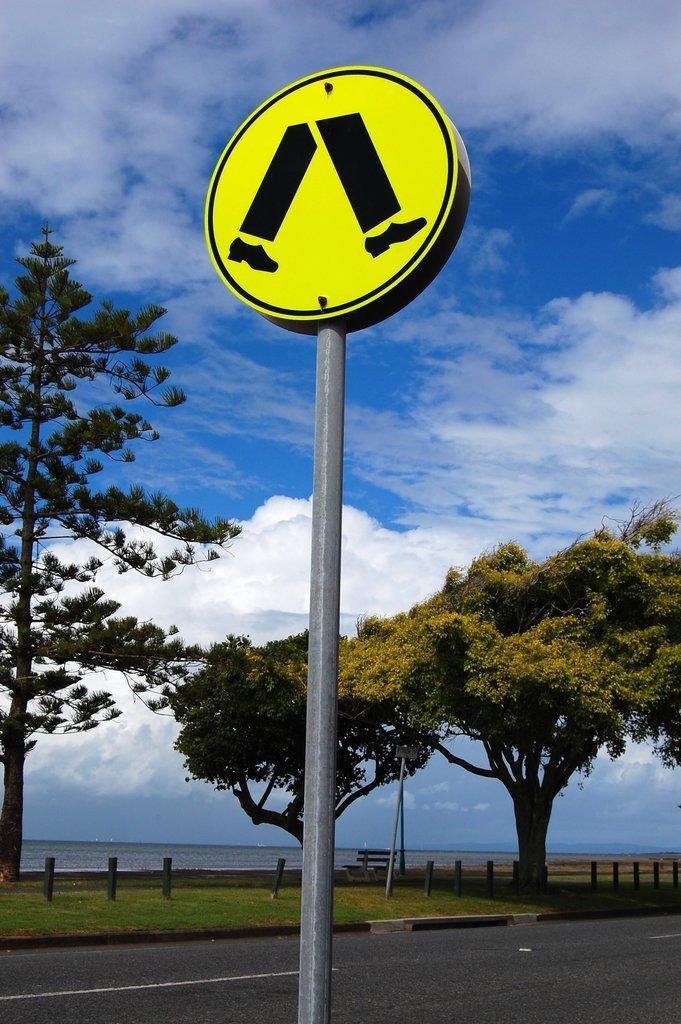In one or two sentences, can you explain what this image depicts? This image is clicked on the road. In the foreground there is a sign board to a pole. Beside the road there's grass on the ground. In the background there are trees, a bench and water. At the top there is the sky. 